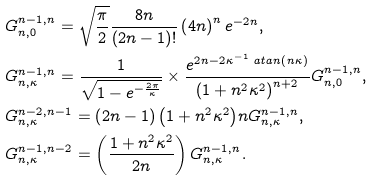<formula> <loc_0><loc_0><loc_500><loc_500>& G _ { n , 0 } ^ { n - 1 , n } = \sqrt { \frac { \pi } { 2 } } \frac { 8 n } { \left ( 2 n - 1 \right ) ! } \left ( 4 n \right ) ^ { n } e ^ { - 2 n } , \\ & G _ { n , \kappa } ^ { n - 1 , n } = \frac { 1 } { \sqrt { 1 - e ^ { - \frac { 2 \pi } { \kappa } } } } \times \frac { e ^ { 2 n - 2 \kappa ^ { - 1 } \ a t a n \left ( n \kappa \right ) } } { \left ( 1 + n ^ { 2 } \kappa ^ { 2 } \right ) ^ { n + 2 } } G _ { n , 0 } ^ { n - 1 , n } , \\ & G _ { n , \kappa } ^ { n - 2 , n - 1 } = { \left ( 2 n - 1 \right ) \left ( 1 + n ^ { 2 } \kappa ^ { 2 } \right ) } n G _ { n , \kappa } ^ { n - 1 , n } , \\ & G _ { n , \kappa } ^ { n - 1 , n - 2 } = \left ( \frac { 1 + n ^ { 2 } \kappa ^ { 2 } } { 2 n } \right ) G _ { n , \kappa } ^ { n - 1 , n } .</formula> 